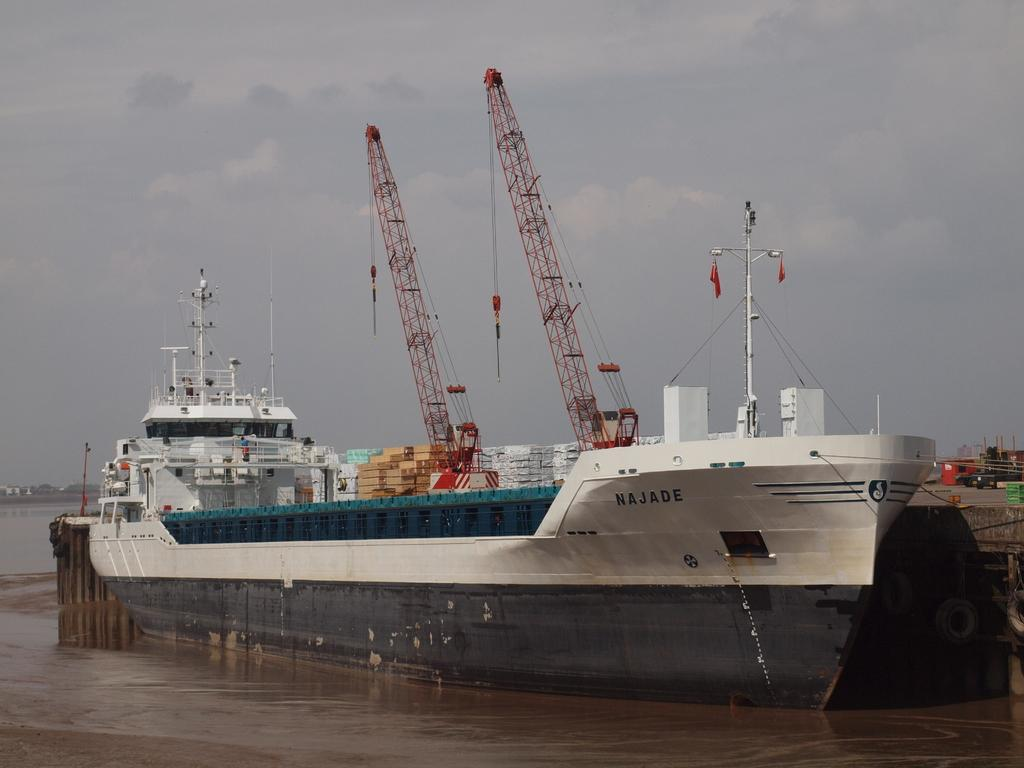What is the main subject of the image? There is a ship in the image. Where is the ship located? The ship is on the water. What can be seen on the ship? There are items on the ship. What structures are present on the right side of the ship? There are poles on the right side of the ship. What is visible behind the ship? The sky is visible behind the ship. Can you tell me how many grapes are hanging from the poles on the right side of the ship? There are no grapes present in the image; the poles are on the ship, which is on the water. What type of can is visible on the ship? There is no can visible on the ship in the image. 